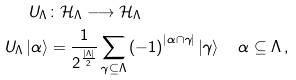<formula> <loc_0><loc_0><loc_500><loc_500>U _ { \Lambda } & \colon \mathcal { H } _ { \Lambda } \longrightarrow \mathcal { H } _ { \Lambda } \\ U _ { \Lambda } \left | \alpha \right \rangle & = \frac { 1 } { 2 ^ { \frac { \left | \Lambda \right | } { 2 } } } \sum _ { \gamma \subseteq \Lambda } \left ( - 1 \right ) ^ { \left | \alpha \cap \gamma \right | } \left | \gamma \right \rangle \quad \alpha \subseteq \Lambda \, ,</formula> 